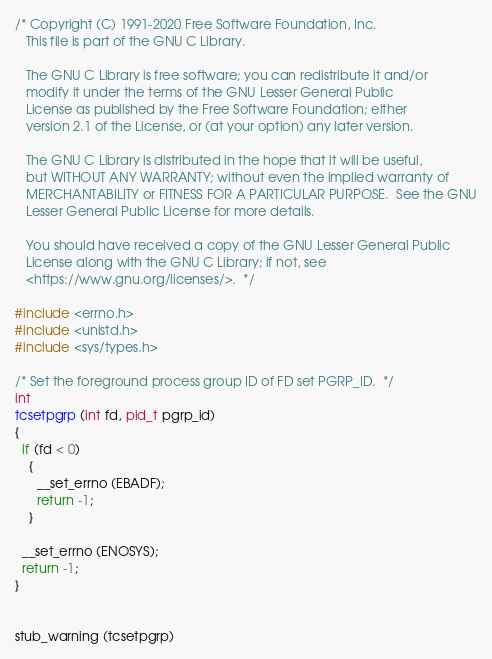<code> <loc_0><loc_0><loc_500><loc_500><_C_>/* Copyright (C) 1991-2020 Free Software Foundation, Inc.
   This file is part of the GNU C Library.

   The GNU C Library is free software; you can redistribute it and/or
   modify it under the terms of the GNU Lesser General Public
   License as published by the Free Software Foundation; either
   version 2.1 of the License, or (at your option) any later version.

   The GNU C Library is distributed in the hope that it will be useful,
   but WITHOUT ANY WARRANTY; without even the implied warranty of
   MERCHANTABILITY or FITNESS FOR A PARTICULAR PURPOSE.  See the GNU
   Lesser General Public License for more details.

   You should have received a copy of the GNU Lesser General Public
   License along with the GNU C Library; if not, see
   <https://www.gnu.org/licenses/>.  */

#include <errno.h>
#include <unistd.h>
#include <sys/types.h>

/* Set the foreground process group ID of FD set PGRP_ID.  */
int
tcsetpgrp (int fd, pid_t pgrp_id)
{
  if (fd < 0)
    {
      __set_errno (EBADF);
      return -1;
    }

  __set_errno (ENOSYS);
  return -1;
}


stub_warning (tcsetpgrp)
</code> 